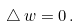Convert formula to latex. <formula><loc_0><loc_0><loc_500><loc_500>\triangle \, w = 0 \, .</formula> 